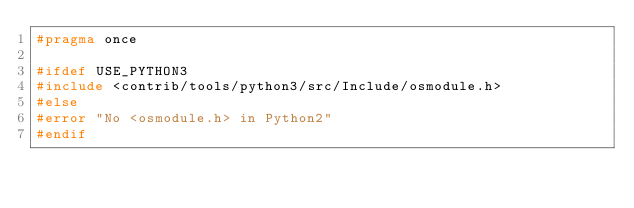Convert code to text. <code><loc_0><loc_0><loc_500><loc_500><_C_>#pragma once

#ifdef USE_PYTHON3
#include <contrib/tools/python3/src/Include/osmodule.h>
#else
#error "No <osmodule.h> in Python2"
#endif
</code> 